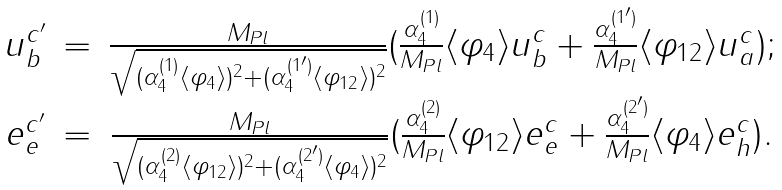<formula> <loc_0><loc_0><loc_500><loc_500>\begin{array} { c c c } u _ { b } ^ { c ^ { \prime } } & = & \frac { M _ { P l } } { \sqrt { ( \alpha ^ { ( 1 ) } _ { 4 } \langle \varphi _ { 4 } \rangle ) ^ { 2 } + ( \alpha ^ { ( 1 ^ { \prime } ) } _ { 4 } \langle \varphi _ { 1 2 } \rangle ) ^ { 2 } } } ( \frac { \alpha ^ { ( 1 ) } _ { 4 } } { M _ { P l } } \langle \varphi _ { 4 } \rangle u ^ { c } _ { b } + \frac { \alpha ^ { ( 1 ^ { \prime } ) } _ { 4 } } { M _ { P l } } \langle \varphi _ { 1 2 } \rangle u ^ { c } _ { a } ) ; \\ e _ { e } ^ { c ^ { \prime } } & = & \frac { M _ { P l } } { \sqrt { ( \alpha ^ { ( 2 ) } _ { 4 } \langle \varphi _ { 1 2 } \rangle ) ^ { 2 } + ( \alpha ^ { ( 2 ^ { \prime } ) } _ { 4 } \langle \varphi _ { 4 } \rangle ) ^ { 2 } } } ( \frac { \alpha ^ { ( 2 ) } _ { 4 } } { M _ { P l } } \langle \varphi _ { 1 2 } \rangle e ^ { c } _ { e } + \frac { \alpha ^ { ( 2 ^ { \prime } ) } _ { 4 } } { M _ { P l } } \langle \varphi _ { 4 } \rangle e ^ { c } _ { h } ) . \end{array}</formula> 